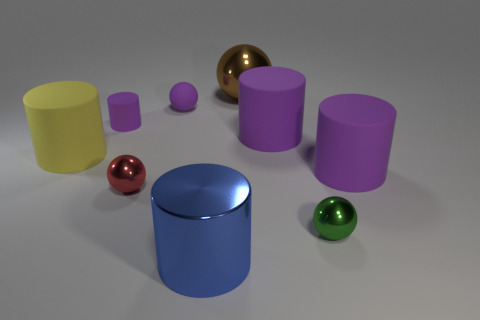Subtract all red spheres. How many purple cylinders are left? 3 Subtract 1 spheres. How many spheres are left? 3 Subtract all yellow cylinders. How many cylinders are left? 4 Subtract all big yellow cylinders. How many cylinders are left? 4 Subtract all green cylinders. Subtract all cyan blocks. How many cylinders are left? 5 Add 1 big things. How many objects exist? 10 Subtract all cylinders. How many objects are left? 4 Add 1 big blue metal cylinders. How many big blue metal cylinders exist? 2 Subtract 0 brown cubes. How many objects are left? 9 Subtract all small red cylinders. Subtract all large yellow rubber cylinders. How many objects are left? 8 